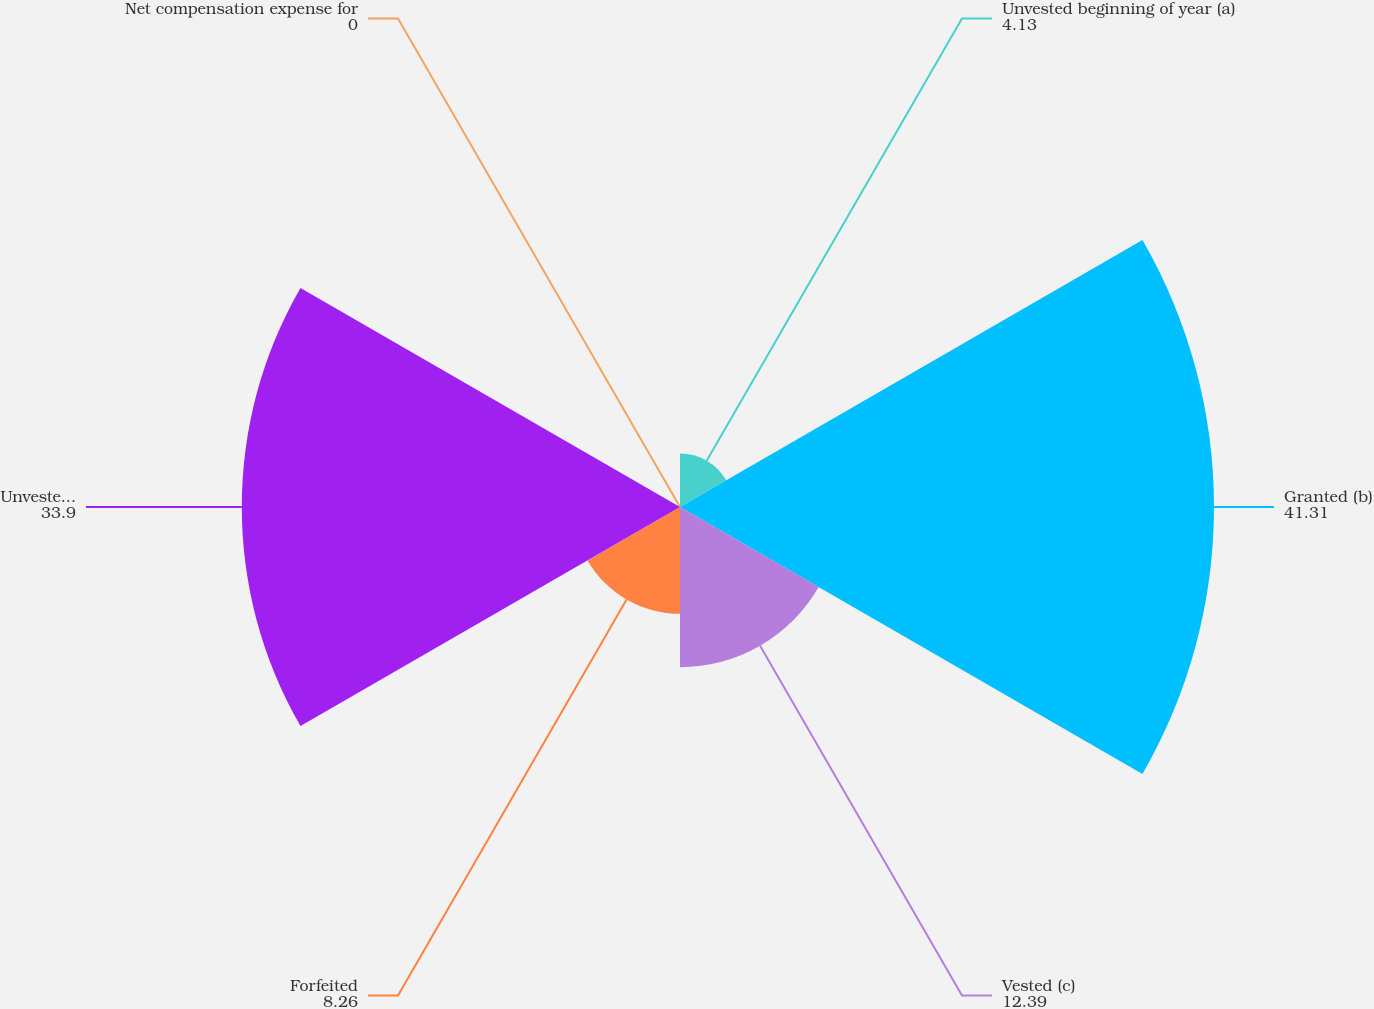Convert chart to OTSL. <chart><loc_0><loc_0><loc_500><loc_500><pie_chart><fcel>Unvested beginning of year (a)<fcel>Granted (b)<fcel>Vested (c)<fcel>Forfeited<fcel>Unvested end of year<fcel>Net compensation expense for<nl><fcel>4.13%<fcel>41.31%<fcel>12.39%<fcel>8.26%<fcel>33.9%<fcel>0.0%<nl></chart> 